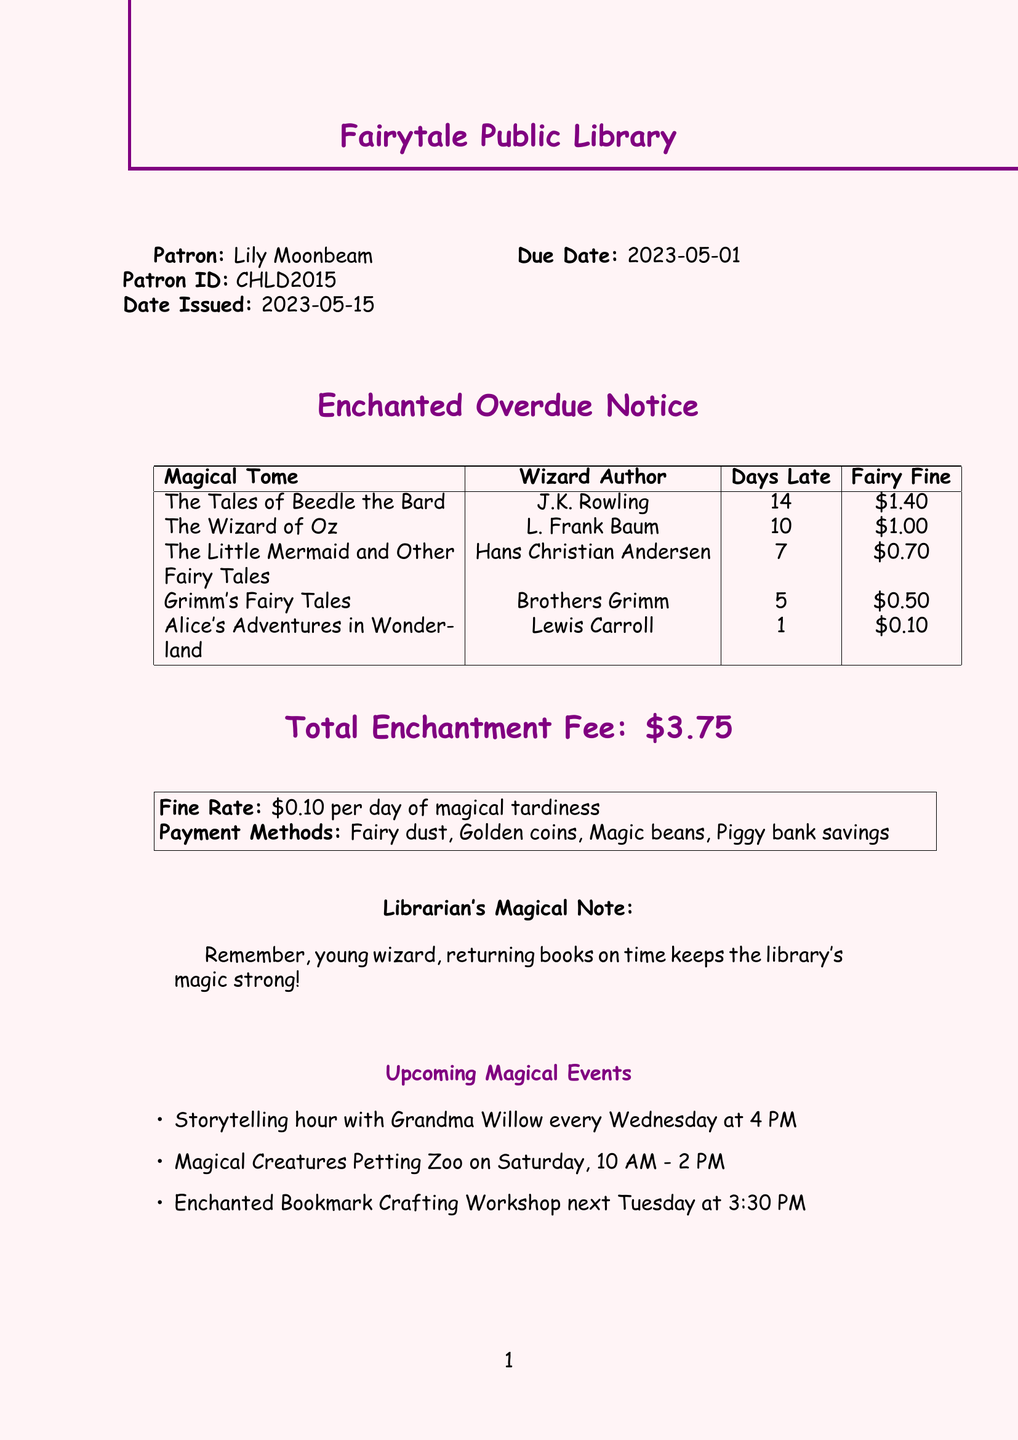What is the patron's name? The patron's name is stated at the beginning of the document.
Answer: Lily Moonbeam What is the total fine amount? The total fine amount is mentioned towards the end of the document.
Answer: $3.75 How many days was "The Wizard of Oz" overdue? The number of days overdue for each book is listed in the table.
Answer: 10 What is the fine rate per day? The fine rate is specified in the document under the fine details.
Answer: $0.10 per day What is the title of the last book listed? The title of the last book in the overdue items table is the last item mentioned.
Answer: Alice's Adventures in Wonderland How many books are overdue? The number of overdue items is determined by counting the entries in the overdue items table.
Answer: 5 Who is the author of "Grimm's Fairy Tales"? The author is specified in the table next to the title of the book.
Answer: Brothers Grimm What is a payment method listed on the receipt? The payment methods are listed in a specific section of the document.
Answer: Fairy dust What event occurs every Wednesday? The upcoming events section mentions the recurring event.
Answer: Storytelling hour with Grandma Willow 